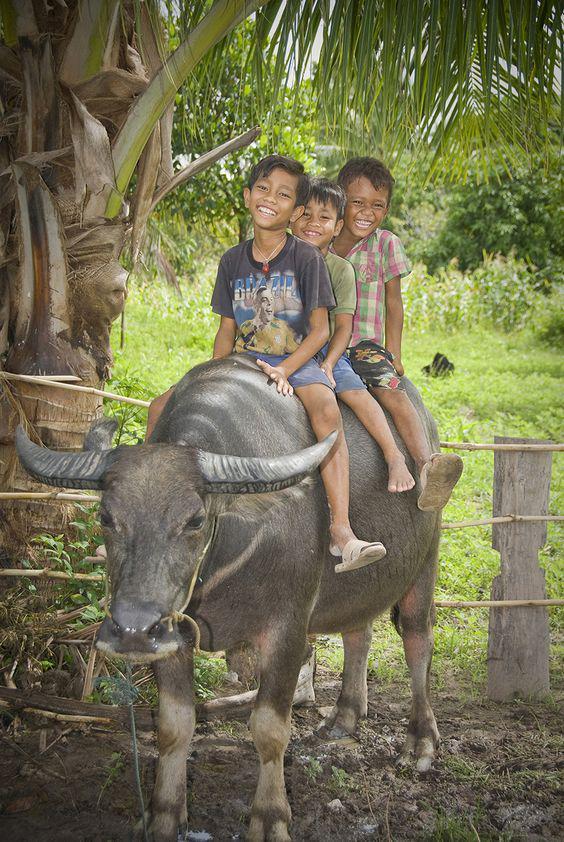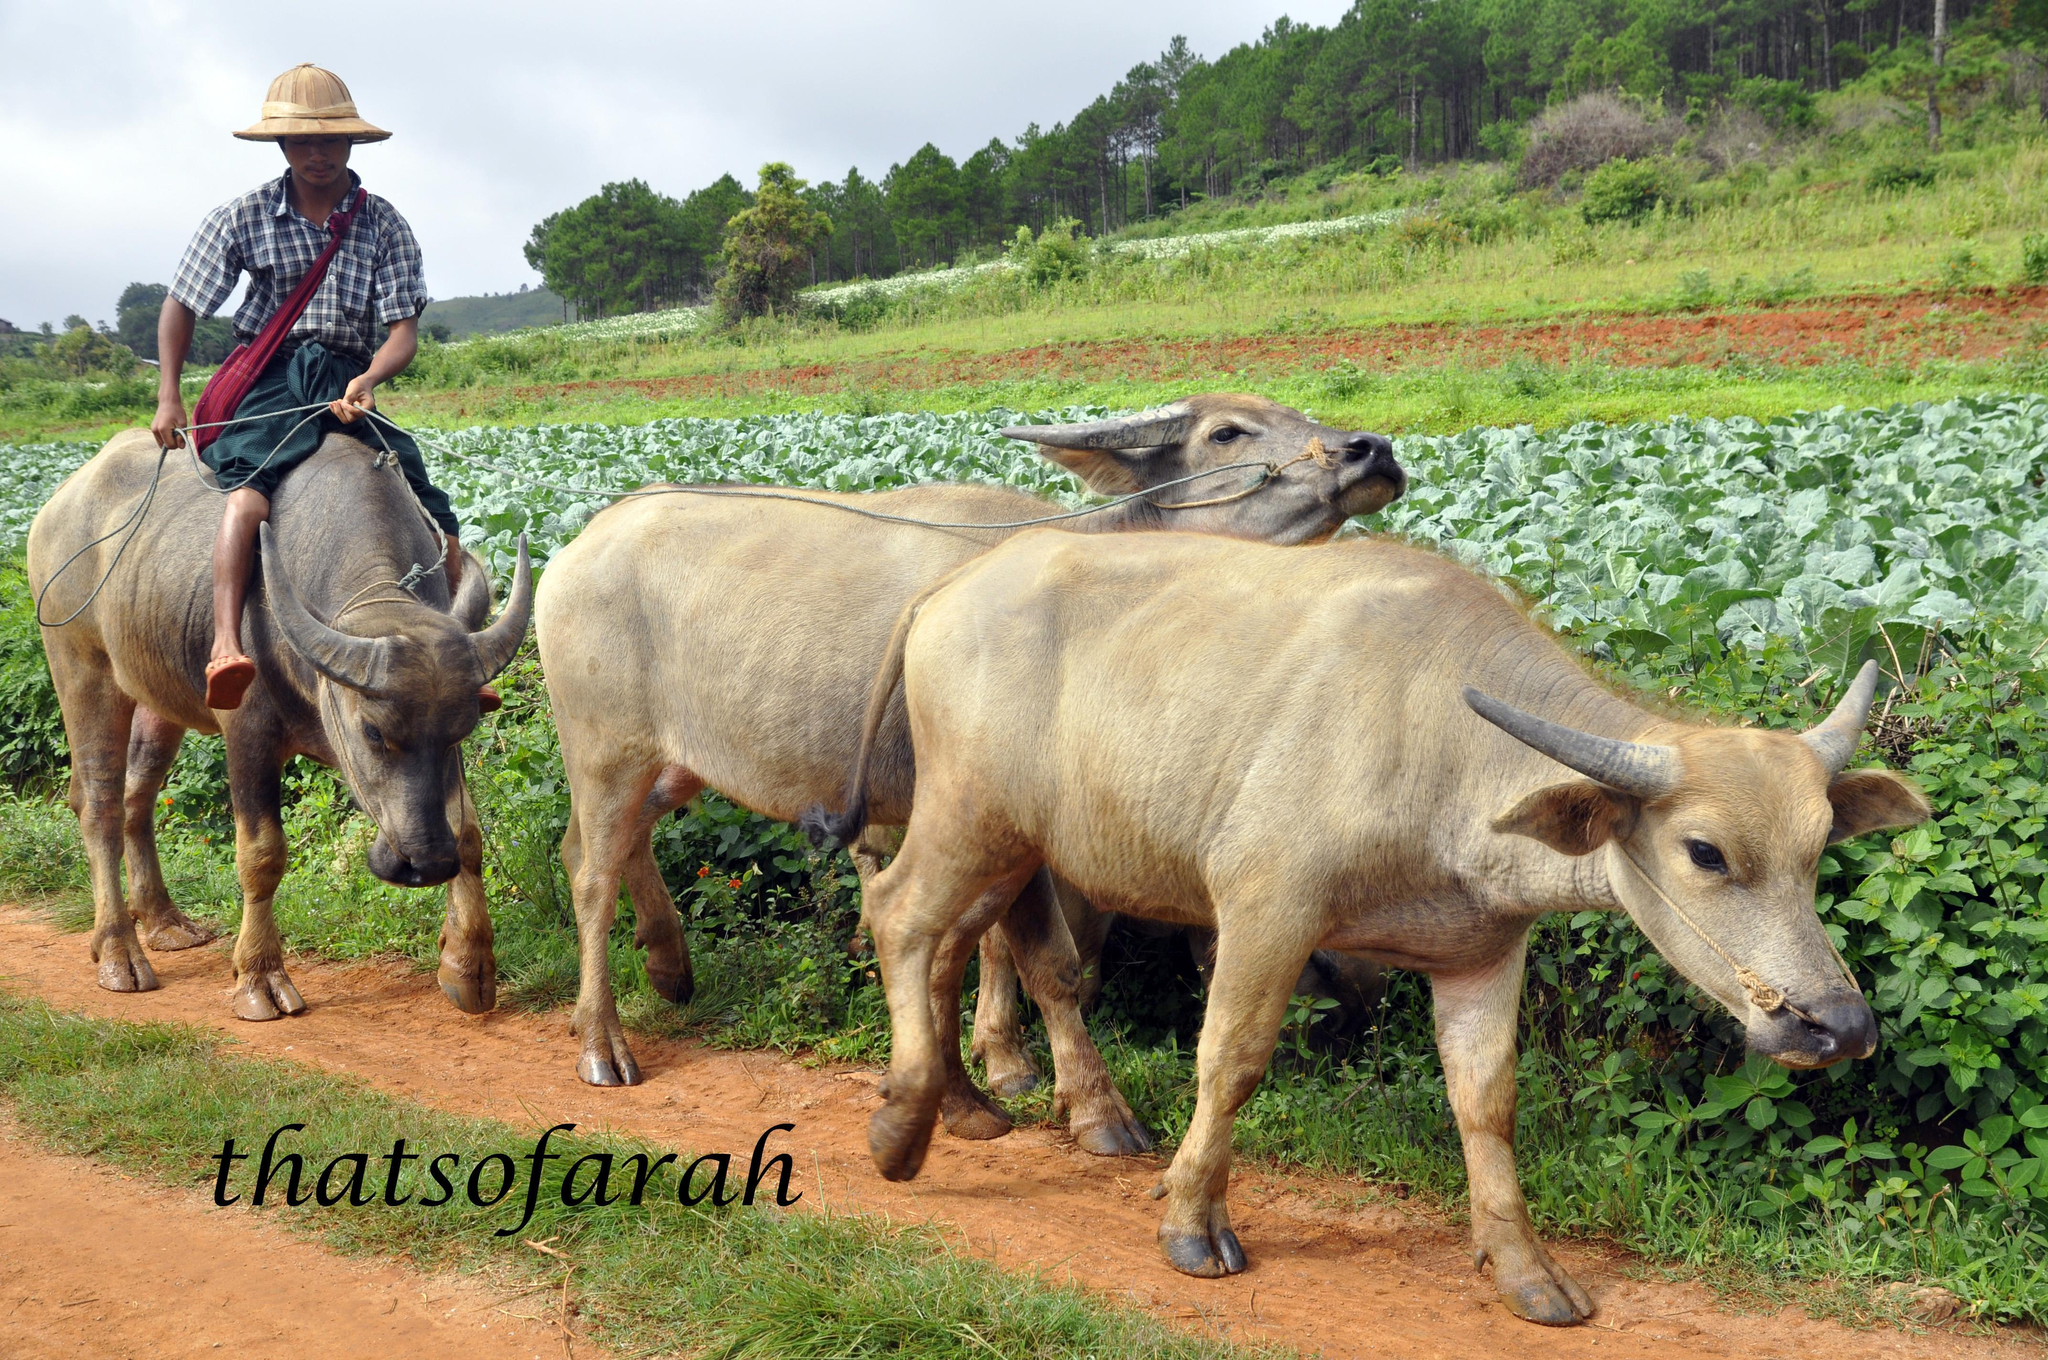The first image is the image on the left, the second image is the image on the right. Assess this claim about the two images: "An ox is being ridden by at least one picture in all images.". Correct or not? Answer yes or no. Yes. The first image is the image on the left, the second image is the image on the right. Assess this claim about the two images: "At least two people are riding together on the back of one horned animal in a scene.". Correct or not? Answer yes or no. Yes. 